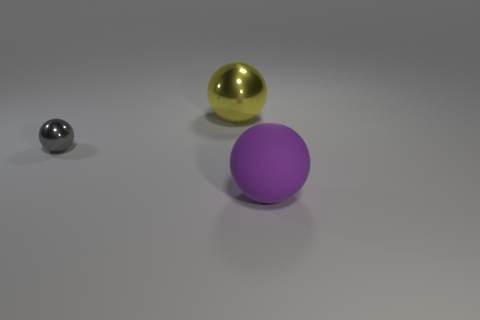Add 3 big brown shiny spheres. How many objects exist? 6 Add 2 big things. How many big things are left? 4 Add 2 tiny cyan metallic things. How many tiny cyan metallic things exist? 2 Subtract 0 gray cubes. How many objects are left? 3 Subtract all green shiny balls. Subtract all big objects. How many objects are left? 1 